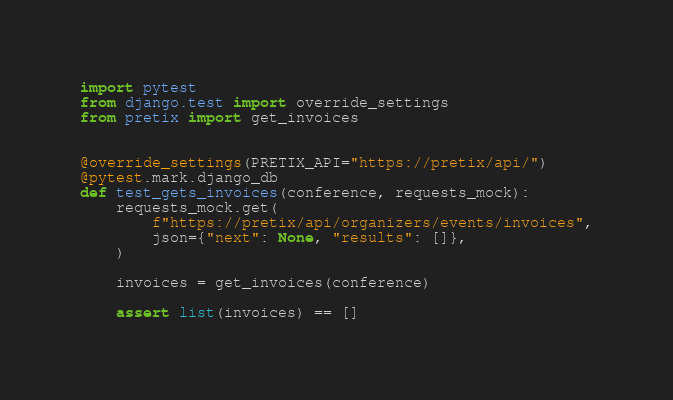Convert code to text. <code><loc_0><loc_0><loc_500><loc_500><_Python_>import pytest
from django.test import override_settings
from pretix import get_invoices


@override_settings(PRETIX_API="https://pretix/api/")
@pytest.mark.django_db
def test_gets_invoices(conference, requests_mock):
    requests_mock.get(
        f"https://pretix/api/organizers/events/invoices",
        json={"next": None, "results": []},
    )

    invoices = get_invoices(conference)

    assert list(invoices) == []
</code> 